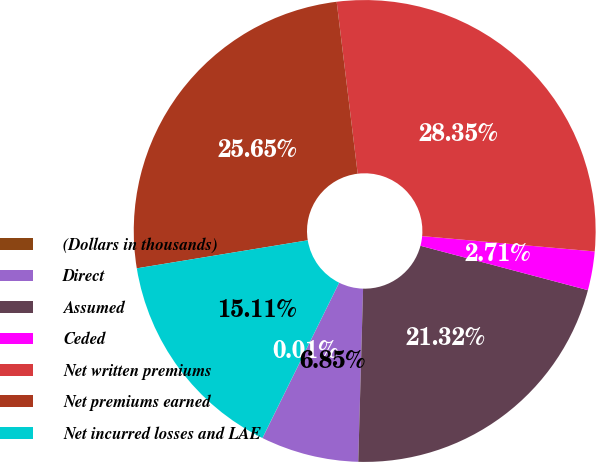Convert chart to OTSL. <chart><loc_0><loc_0><loc_500><loc_500><pie_chart><fcel>(Dollars in thousands)<fcel>Direct<fcel>Assumed<fcel>Ceded<fcel>Net written premiums<fcel>Net premiums earned<fcel>Net incurred losses and LAE<nl><fcel>0.01%<fcel>6.85%<fcel>21.32%<fcel>2.71%<fcel>28.35%<fcel>25.65%<fcel>15.11%<nl></chart> 